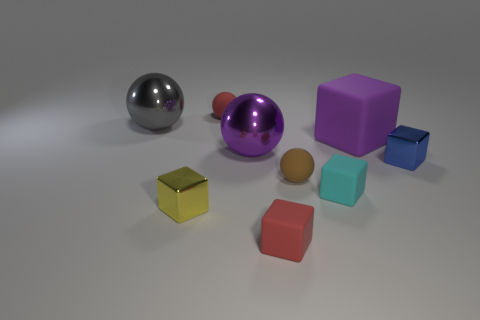Subtract all blue blocks. How many blocks are left? 4 Subtract all gray spheres. How many spheres are left? 3 Subtract all cubes. How many objects are left? 4 Subtract 2 cubes. How many cubes are left? 3 Add 1 purple spheres. How many objects exist? 10 Subtract 1 gray spheres. How many objects are left? 8 Subtract all red cubes. Subtract all brown cylinders. How many cubes are left? 4 Subtract all gray cubes. How many blue balls are left? 0 Subtract all small red balls. Subtract all large gray objects. How many objects are left? 7 Add 5 tiny cyan matte things. How many tiny cyan matte things are left? 6 